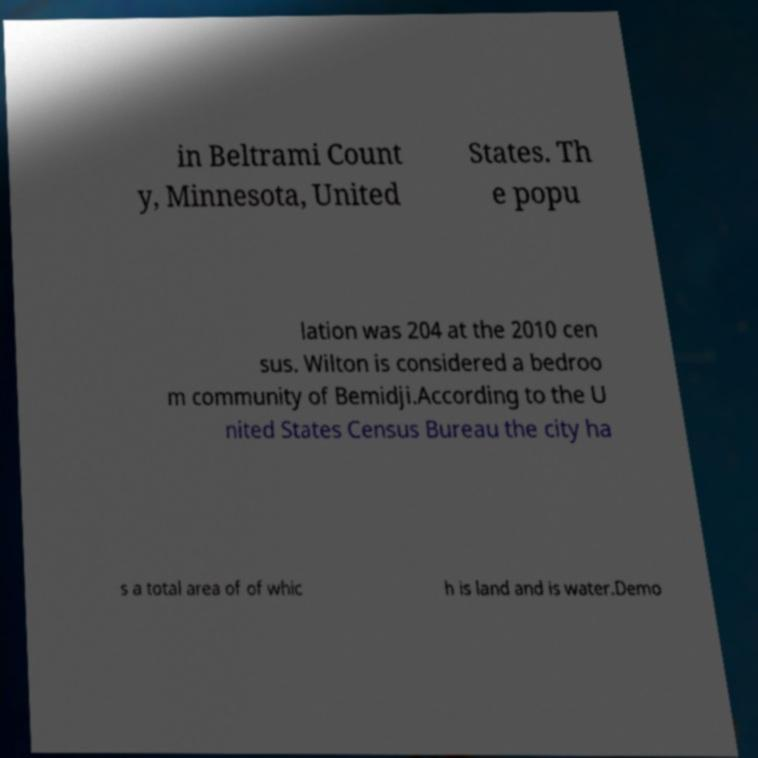I need the written content from this picture converted into text. Can you do that? in Beltrami Count y, Minnesota, United States. Th e popu lation was 204 at the 2010 cen sus. Wilton is considered a bedroo m community of Bemidji.According to the U nited States Census Bureau the city ha s a total area of of whic h is land and is water.Demo 